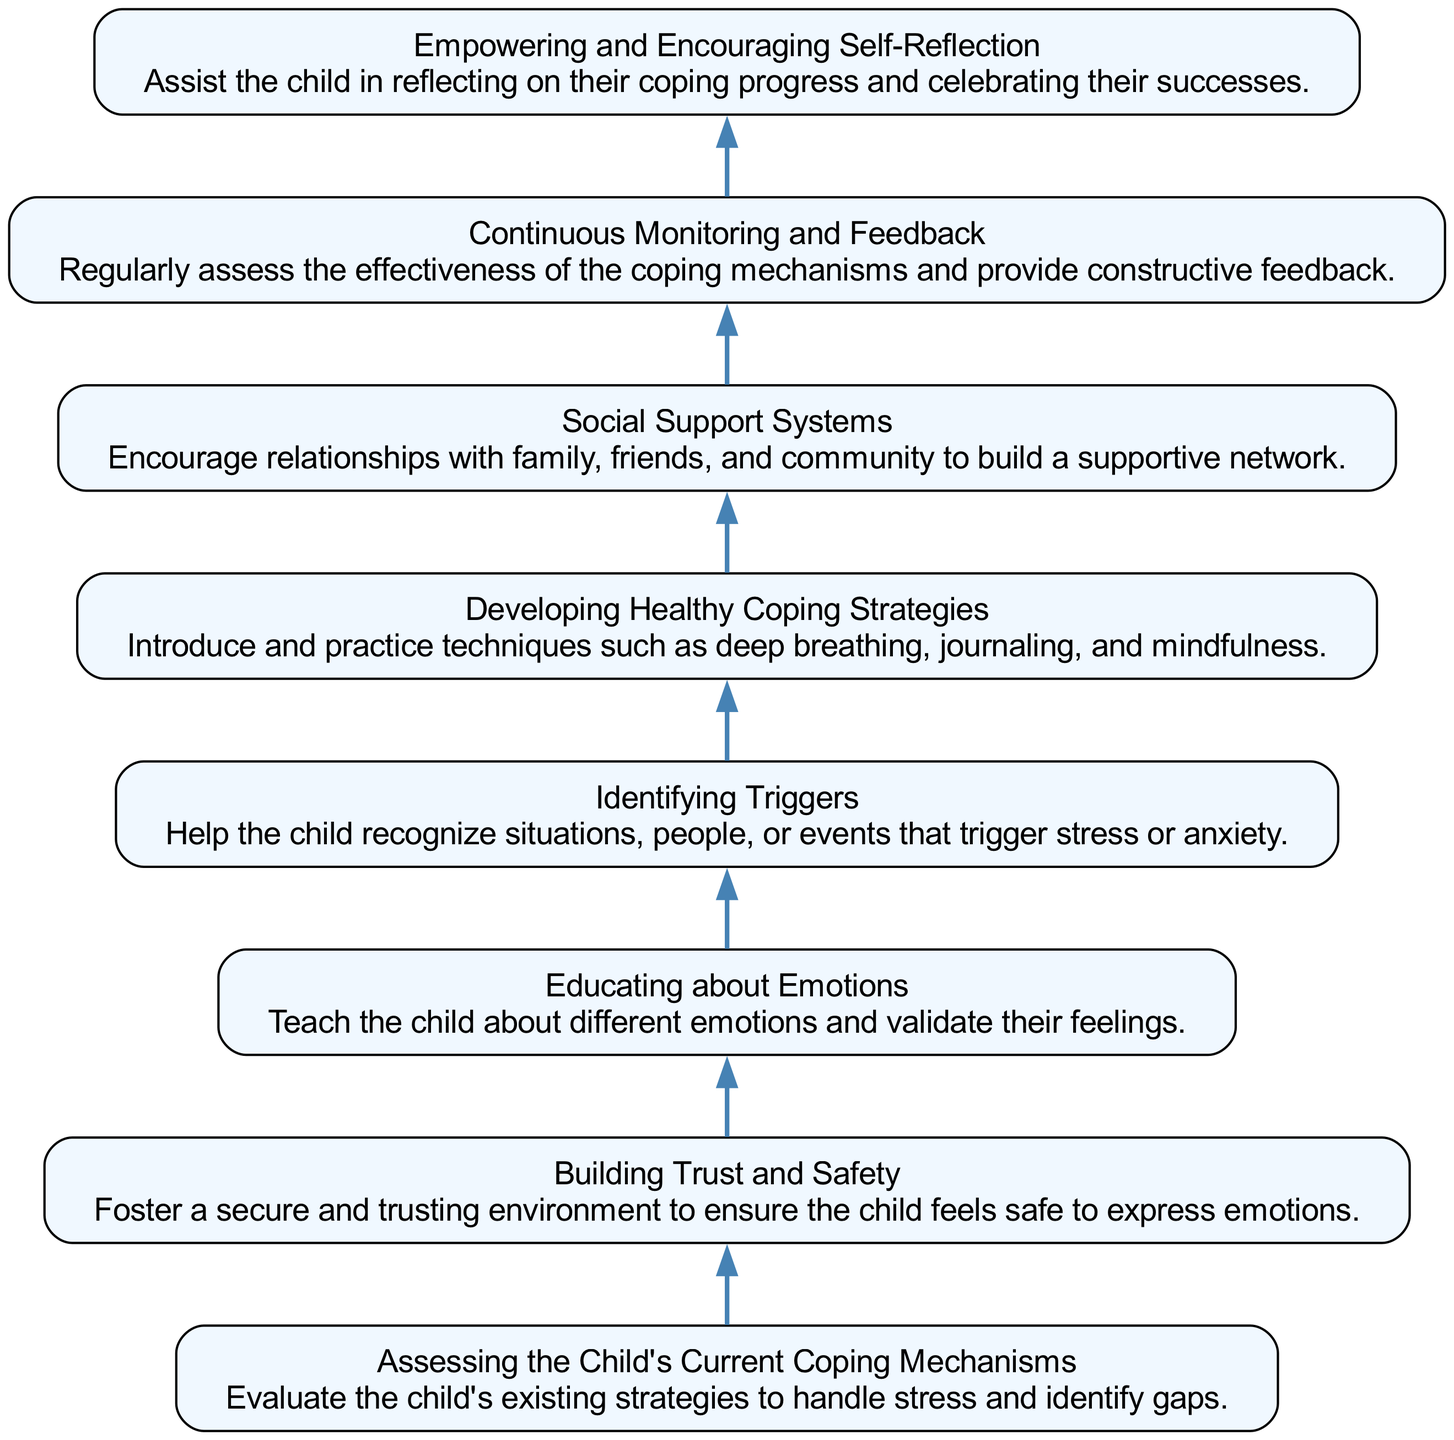What is the title of the first step in the diagram? The first step is represented at the bottom of the diagram and is titled "Assessing the Child's Current Coping Mechanisms." This is confirmed by examining the nodes in their order from bottom to top.
Answer: Assessing the Child's Current Coping Mechanisms How many steps are there in the coping mechanisms flow chart? By counting the nodes listed from the bottom to top, there are a total of eight steps represented in the diagram.
Answer: 8 Which step follows "Building Trust and Safety"? The next step in the flow after "Building Trust and Safety" (the second node) is "Educating about Emotions." This is determined by following the connection from the second node to the next one above it.
Answer: Educating about Emotions What is the last step indicated in the diagram? The last step in the flow chart is "Empowering and Encouraging Self-Reflection," which is positioned at the top of the diagram. This can be seen as the final node in the upward flow.
Answer: Empowering and Encouraging Self-Reflection What is the primary focus of "Identifying Triggers"? The focus of "Identifying Triggers" is to help the child recognize situations, people, or events that trigger stress or anxiety, as indicated in the description of the respective node.
Answer: Recognizing triggers What are the two actions comprised within “Developing Healthy Coping Strategies”? "Developing Healthy Coping Strategies" includes introducing and practicing techniques such as deep breathing, journaling, and mindfulness, as described in its node.
Answer: Deep breathing and journaling How does "Continuous Monitoring and Feedback" relate to previous steps? "Continuous Monitoring and Feedback" assesses the effectiveness of the coping mechanisms developed in earlier steps and ensures they are working well, making it a combination of evaluation and support derived from what has been learned.
Answer: Assesses effectiveness Which step promotes relationships with others? The step that promotes relationships with others is "Social Support Systems," which encourages connections with family, friends, and the community. This is evident from the node's title.
Answer: Social Support Systems 